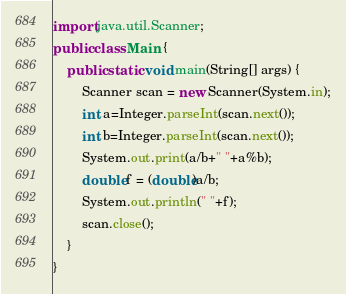Convert code to text. <code><loc_0><loc_0><loc_500><loc_500><_Java_>import java.util.Scanner;
public class Main {
	public static void main(String[] args) {
		Scanner scan = new Scanner(System.in);
		int a=Integer.parseInt(scan.next());
		int b=Integer.parseInt(scan.next());
		System.out.print(a/b+" "+a%b);
		double f = (double)a/b;
		System.out.println(" "+f);
		scan.close();
	}
}</code> 